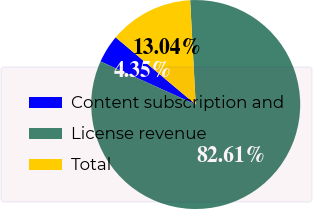<chart> <loc_0><loc_0><loc_500><loc_500><pie_chart><fcel>Content subscription and<fcel>License revenue<fcel>Total<nl><fcel>4.35%<fcel>82.61%<fcel>13.04%<nl></chart> 